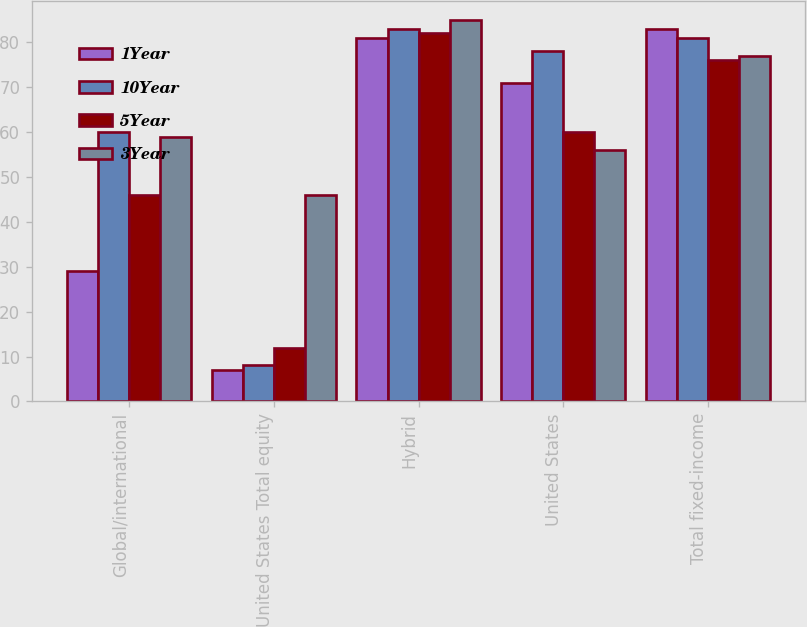Convert chart. <chart><loc_0><loc_0><loc_500><loc_500><stacked_bar_chart><ecel><fcel>Global/international<fcel>United States Total equity<fcel>Hybrid<fcel>United States<fcel>Total fixed-income<nl><fcel>1Year<fcel>29<fcel>7<fcel>81<fcel>71<fcel>83<nl><fcel>10Year<fcel>60<fcel>8<fcel>83<fcel>78<fcel>81<nl><fcel>5Year<fcel>46<fcel>12<fcel>82<fcel>60<fcel>76<nl><fcel>3Year<fcel>59<fcel>46<fcel>85<fcel>56<fcel>77<nl></chart> 